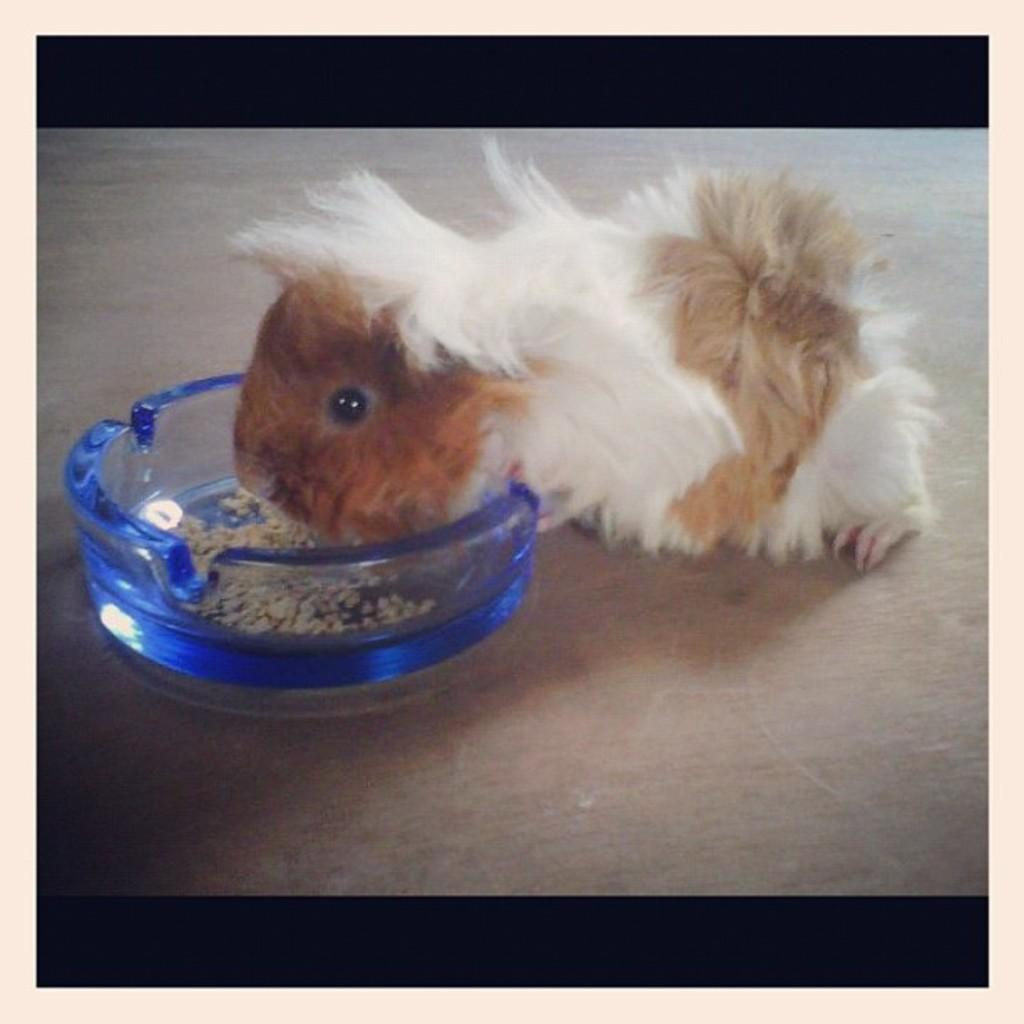What type of animal is in the image? There is a Guinea pig in the image. What is the Guinea pig doing in the image? The Guinea pig is eating food. How is the food being served to the Guinea pig? The food is in a glass bowl. How does the Guinea pig adjust the cub in the image? There is no cub present in the image, and therefore no such adjustment can be observed. 